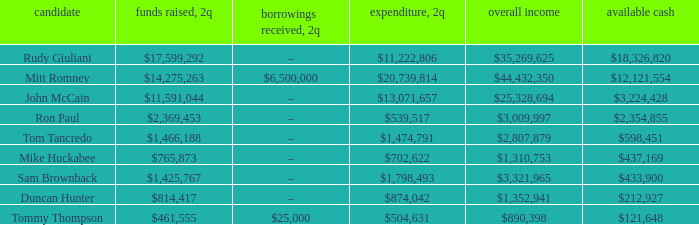Tell me the total receipts for tom tancredo $2,807,879. 